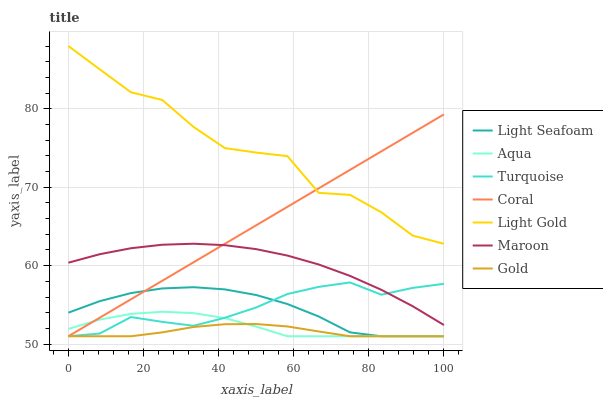Does Coral have the minimum area under the curve?
Answer yes or no. No. Does Coral have the maximum area under the curve?
Answer yes or no. No. Is Gold the smoothest?
Answer yes or no. No. Is Gold the roughest?
Answer yes or no. No. Does Maroon have the lowest value?
Answer yes or no. No. Does Coral have the highest value?
Answer yes or no. No. Is Aqua less than Maroon?
Answer yes or no. Yes. Is Light Gold greater than Maroon?
Answer yes or no. Yes. Does Aqua intersect Maroon?
Answer yes or no. No. 